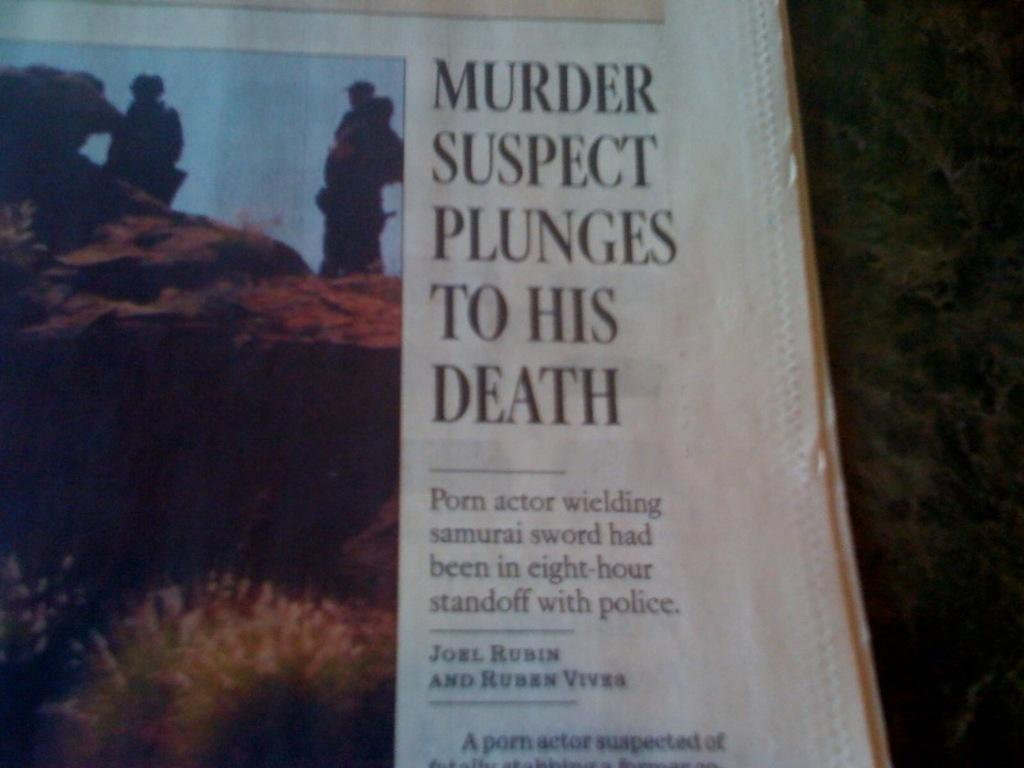<image>
Render a clear and concise summary of the photo. A newspaper article announces that A Murder Suspect Plunges to His Death. 